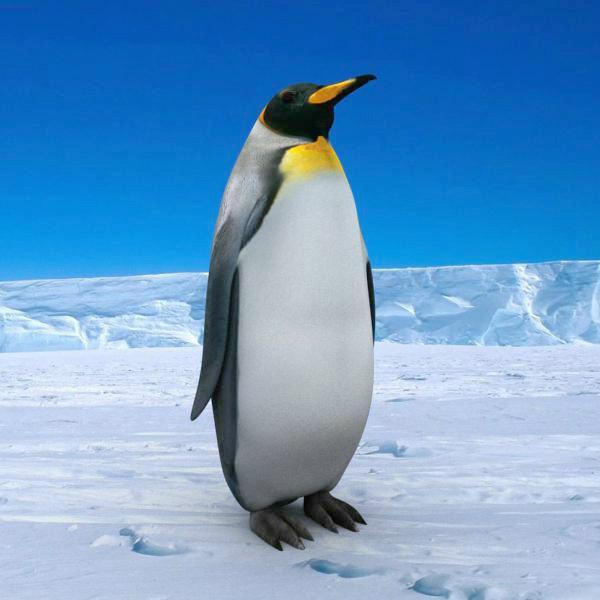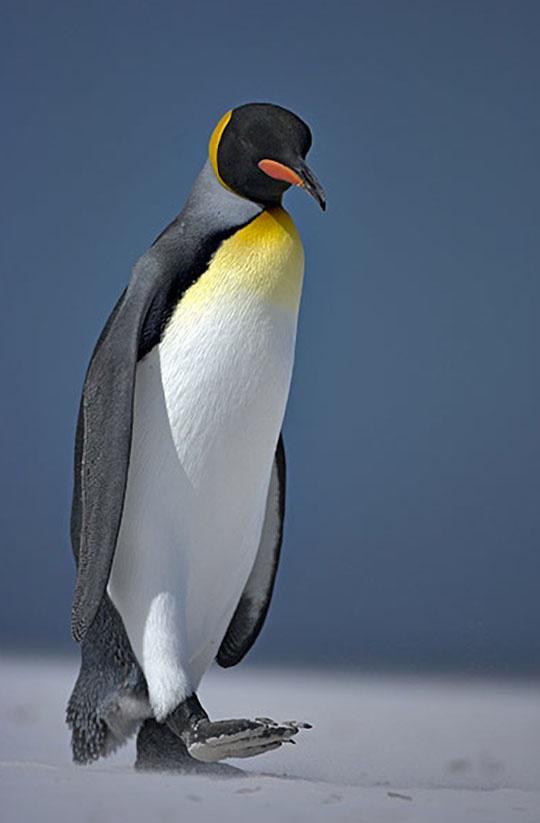The first image is the image on the left, the second image is the image on the right. Evaluate the accuracy of this statement regarding the images: "There is a penguin that is walking forward.". Is it true? Answer yes or no. Yes. The first image is the image on the left, the second image is the image on the right. Examine the images to the left and right. Is the description "Each image shows an upright penguin that is standing in one place rather than walking." accurate? Answer yes or no. No. 